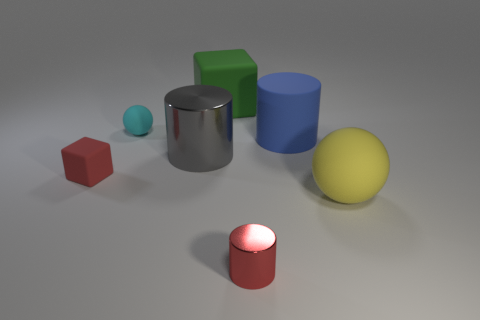There is a cyan rubber thing; does it have the same size as the block that is in front of the big rubber cylinder?
Offer a very short reply. Yes. What color is the matte block that is behind the tiny red thing behind the big matte ball?
Keep it short and to the point. Green. Is the size of the red block the same as the green matte block?
Offer a very short reply. No. There is a large object that is both to the left of the blue cylinder and in front of the green rubber thing; what is its color?
Give a very brief answer. Gray. What size is the green matte cube?
Give a very brief answer. Large. There is a tiny rubber thing in front of the big blue rubber cylinder; does it have the same color as the tiny shiny object?
Offer a terse response. Yes. Are there more tiny objects that are on the right side of the big green cube than tiny rubber balls that are to the left of the red rubber thing?
Provide a short and direct response. Yes. Are there more green matte objects than big green cylinders?
Provide a succinct answer. Yes. How big is the rubber thing that is right of the large rubber block and left of the yellow rubber thing?
Your response must be concise. Large. What shape is the tiny red metallic object?
Provide a succinct answer. Cylinder. 